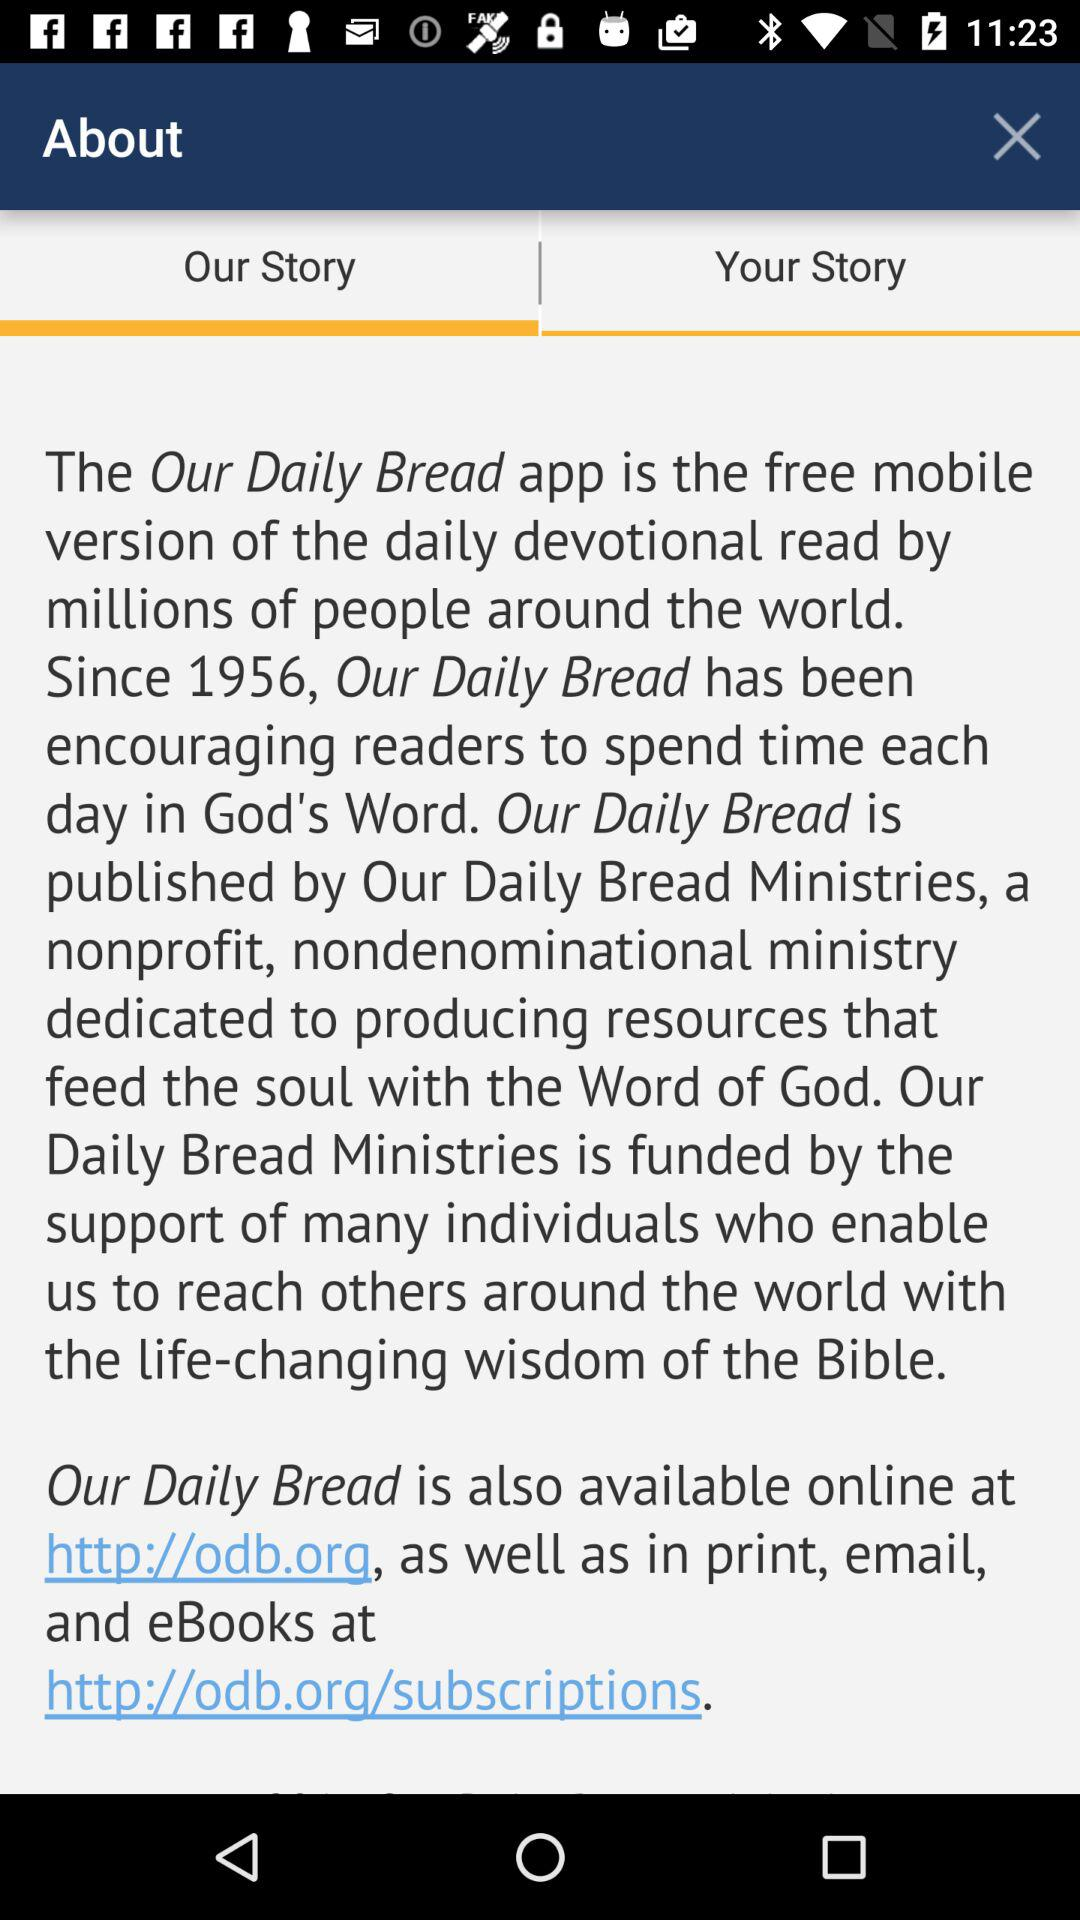What is the name of the app? The name of the app is "Our Daily Bread". 